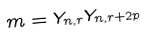Convert formula to latex. <formula><loc_0><loc_0><loc_500><loc_500>m = Y _ { n , r } Y _ { n , r + 2 p }</formula> 